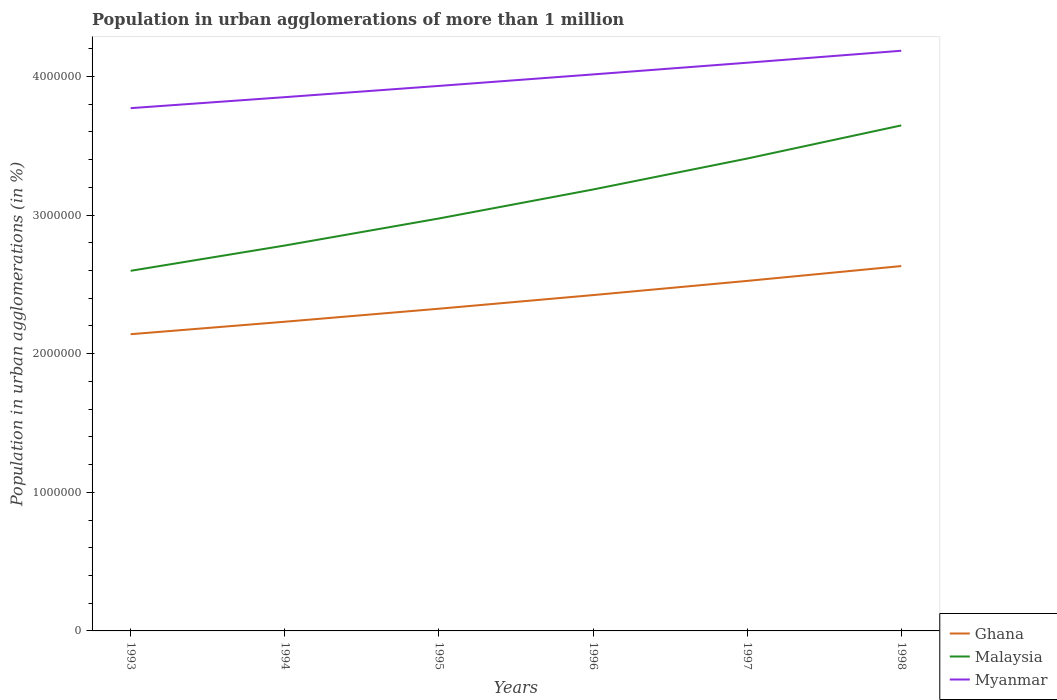How many different coloured lines are there?
Offer a very short reply. 3. Is the number of lines equal to the number of legend labels?
Provide a succinct answer. Yes. Across all years, what is the maximum population in urban agglomerations in Myanmar?
Your answer should be very brief. 3.77e+06. In which year was the population in urban agglomerations in Malaysia maximum?
Provide a succinct answer. 1993. What is the total population in urban agglomerations in Ghana in the graph?
Your answer should be very brief. -4.02e+05. What is the difference between the highest and the second highest population in urban agglomerations in Ghana?
Your answer should be very brief. 4.91e+05. Is the population in urban agglomerations in Malaysia strictly greater than the population in urban agglomerations in Myanmar over the years?
Give a very brief answer. Yes. What is the difference between two consecutive major ticks on the Y-axis?
Your answer should be compact. 1.00e+06. Where does the legend appear in the graph?
Make the answer very short. Bottom right. How many legend labels are there?
Your response must be concise. 3. How are the legend labels stacked?
Keep it short and to the point. Vertical. What is the title of the graph?
Keep it short and to the point. Population in urban agglomerations of more than 1 million. Does "Sao Tome and Principe" appear as one of the legend labels in the graph?
Your answer should be compact. No. What is the label or title of the Y-axis?
Offer a very short reply. Population in urban agglomerations (in %). What is the Population in urban agglomerations (in %) in Ghana in 1993?
Your answer should be very brief. 2.14e+06. What is the Population in urban agglomerations (in %) in Malaysia in 1993?
Your answer should be compact. 2.60e+06. What is the Population in urban agglomerations (in %) in Myanmar in 1993?
Give a very brief answer. 3.77e+06. What is the Population in urban agglomerations (in %) of Ghana in 1994?
Provide a short and direct response. 2.23e+06. What is the Population in urban agglomerations (in %) in Malaysia in 1994?
Offer a very short reply. 2.78e+06. What is the Population in urban agglomerations (in %) of Myanmar in 1994?
Ensure brevity in your answer.  3.85e+06. What is the Population in urban agglomerations (in %) of Ghana in 1995?
Provide a succinct answer. 2.32e+06. What is the Population in urban agglomerations (in %) of Malaysia in 1995?
Keep it short and to the point. 2.97e+06. What is the Population in urban agglomerations (in %) of Myanmar in 1995?
Make the answer very short. 3.93e+06. What is the Population in urban agglomerations (in %) in Ghana in 1996?
Offer a terse response. 2.42e+06. What is the Population in urban agglomerations (in %) of Malaysia in 1996?
Your response must be concise. 3.18e+06. What is the Population in urban agglomerations (in %) in Myanmar in 1996?
Your answer should be very brief. 4.01e+06. What is the Population in urban agglomerations (in %) in Ghana in 1997?
Your answer should be very brief. 2.52e+06. What is the Population in urban agglomerations (in %) in Malaysia in 1997?
Your answer should be compact. 3.41e+06. What is the Population in urban agglomerations (in %) in Myanmar in 1997?
Offer a very short reply. 4.10e+06. What is the Population in urban agglomerations (in %) in Ghana in 1998?
Offer a very short reply. 2.63e+06. What is the Population in urban agglomerations (in %) in Malaysia in 1998?
Give a very brief answer. 3.65e+06. What is the Population in urban agglomerations (in %) of Myanmar in 1998?
Offer a very short reply. 4.18e+06. Across all years, what is the maximum Population in urban agglomerations (in %) of Ghana?
Ensure brevity in your answer.  2.63e+06. Across all years, what is the maximum Population in urban agglomerations (in %) of Malaysia?
Make the answer very short. 3.65e+06. Across all years, what is the maximum Population in urban agglomerations (in %) in Myanmar?
Keep it short and to the point. 4.18e+06. Across all years, what is the minimum Population in urban agglomerations (in %) of Ghana?
Provide a short and direct response. 2.14e+06. Across all years, what is the minimum Population in urban agglomerations (in %) of Malaysia?
Your response must be concise. 2.60e+06. Across all years, what is the minimum Population in urban agglomerations (in %) in Myanmar?
Ensure brevity in your answer.  3.77e+06. What is the total Population in urban agglomerations (in %) of Ghana in the graph?
Provide a short and direct response. 1.43e+07. What is the total Population in urban agglomerations (in %) in Malaysia in the graph?
Make the answer very short. 1.86e+07. What is the total Population in urban agglomerations (in %) in Myanmar in the graph?
Your answer should be compact. 2.38e+07. What is the difference between the Population in urban agglomerations (in %) in Ghana in 1993 and that in 1994?
Your answer should be compact. -8.99e+04. What is the difference between the Population in urban agglomerations (in %) in Malaysia in 1993 and that in 1994?
Your answer should be compact. -1.82e+05. What is the difference between the Population in urban agglomerations (in %) in Myanmar in 1993 and that in 1994?
Offer a very short reply. -7.94e+04. What is the difference between the Population in urban agglomerations (in %) in Ghana in 1993 and that in 1995?
Provide a succinct answer. -1.84e+05. What is the difference between the Population in urban agglomerations (in %) in Malaysia in 1993 and that in 1995?
Offer a terse response. -3.77e+05. What is the difference between the Population in urban agglomerations (in %) of Myanmar in 1993 and that in 1995?
Ensure brevity in your answer.  -1.60e+05. What is the difference between the Population in urban agglomerations (in %) of Ghana in 1993 and that in 1996?
Ensure brevity in your answer.  -2.82e+05. What is the difference between the Population in urban agglomerations (in %) of Malaysia in 1993 and that in 1996?
Your response must be concise. -5.86e+05. What is the difference between the Population in urban agglomerations (in %) of Myanmar in 1993 and that in 1996?
Provide a succinct answer. -2.43e+05. What is the difference between the Population in urban agglomerations (in %) of Ghana in 1993 and that in 1997?
Your answer should be compact. -3.84e+05. What is the difference between the Population in urban agglomerations (in %) of Malaysia in 1993 and that in 1997?
Offer a very short reply. -8.10e+05. What is the difference between the Population in urban agglomerations (in %) of Myanmar in 1993 and that in 1997?
Your response must be concise. -3.28e+05. What is the difference between the Population in urban agglomerations (in %) in Ghana in 1993 and that in 1998?
Offer a very short reply. -4.91e+05. What is the difference between the Population in urban agglomerations (in %) in Malaysia in 1993 and that in 1998?
Provide a short and direct response. -1.05e+06. What is the difference between the Population in urban agglomerations (in %) in Myanmar in 1993 and that in 1998?
Provide a succinct answer. -4.14e+05. What is the difference between the Population in urban agglomerations (in %) in Ghana in 1994 and that in 1995?
Make the answer very short. -9.39e+04. What is the difference between the Population in urban agglomerations (in %) in Malaysia in 1994 and that in 1995?
Your answer should be very brief. -1.95e+05. What is the difference between the Population in urban agglomerations (in %) in Myanmar in 1994 and that in 1995?
Ensure brevity in your answer.  -8.11e+04. What is the difference between the Population in urban agglomerations (in %) in Ghana in 1994 and that in 1996?
Keep it short and to the point. -1.92e+05. What is the difference between the Population in urban agglomerations (in %) in Malaysia in 1994 and that in 1996?
Give a very brief answer. -4.04e+05. What is the difference between the Population in urban agglomerations (in %) of Myanmar in 1994 and that in 1996?
Offer a terse response. -1.64e+05. What is the difference between the Population in urban agglomerations (in %) in Ghana in 1994 and that in 1997?
Offer a very short reply. -2.95e+05. What is the difference between the Population in urban agglomerations (in %) in Malaysia in 1994 and that in 1997?
Offer a terse response. -6.27e+05. What is the difference between the Population in urban agglomerations (in %) in Myanmar in 1994 and that in 1997?
Your response must be concise. -2.48e+05. What is the difference between the Population in urban agglomerations (in %) in Ghana in 1994 and that in 1998?
Keep it short and to the point. -4.02e+05. What is the difference between the Population in urban agglomerations (in %) in Malaysia in 1994 and that in 1998?
Make the answer very short. -8.66e+05. What is the difference between the Population in urban agglomerations (in %) in Myanmar in 1994 and that in 1998?
Your answer should be compact. -3.35e+05. What is the difference between the Population in urban agglomerations (in %) in Ghana in 1995 and that in 1996?
Give a very brief answer. -9.82e+04. What is the difference between the Population in urban agglomerations (in %) in Malaysia in 1995 and that in 1996?
Your response must be concise. -2.09e+05. What is the difference between the Population in urban agglomerations (in %) in Myanmar in 1995 and that in 1996?
Offer a very short reply. -8.29e+04. What is the difference between the Population in urban agglomerations (in %) in Ghana in 1995 and that in 1997?
Your answer should be compact. -2.01e+05. What is the difference between the Population in urban agglomerations (in %) of Malaysia in 1995 and that in 1997?
Make the answer very short. -4.32e+05. What is the difference between the Population in urban agglomerations (in %) of Myanmar in 1995 and that in 1997?
Provide a succinct answer. -1.67e+05. What is the difference between the Population in urban agglomerations (in %) in Ghana in 1995 and that in 1998?
Provide a succinct answer. -3.08e+05. What is the difference between the Population in urban agglomerations (in %) of Malaysia in 1995 and that in 1998?
Give a very brief answer. -6.71e+05. What is the difference between the Population in urban agglomerations (in %) of Myanmar in 1995 and that in 1998?
Your answer should be very brief. -2.54e+05. What is the difference between the Population in urban agglomerations (in %) of Ghana in 1996 and that in 1997?
Your answer should be compact. -1.02e+05. What is the difference between the Population in urban agglomerations (in %) of Malaysia in 1996 and that in 1997?
Keep it short and to the point. -2.23e+05. What is the difference between the Population in urban agglomerations (in %) of Myanmar in 1996 and that in 1997?
Ensure brevity in your answer.  -8.44e+04. What is the difference between the Population in urban agglomerations (in %) of Ghana in 1996 and that in 1998?
Your answer should be very brief. -2.09e+05. What is the difference between the Population in urban agglomerations (in %) of Malaysia in 1996 and that in 1998?
Keep it short and to the point. -4.62e+05. What is the difference between the Population in urban agglomerations (in %) in Myanmar in 1996 and that in 1998?
Keep it short and to the point. -1.71e+05. What is the difference between the Population in urban agglomerations (in %) in Ghana in 1997 and that in 1998?
Your answer should be very brief. -1.07e+05. What is the difference between the Population in urban agglomerations (in %) in Malaysia in 1997 and that in 1998?
Give a very brief answer. -2.39e+05. What is the difference between the Population in urban agglomerations (in %) of Myanmar in 1997 and that in 1998?
Offer a very short reply. -8.63e+04. What is the difference between the Population in urban agglomerations (in %) of Ghana in 1993 and the Population in urban agglomerations (in %) of Malaysia in 1994?
Offer a terse response. -6.40e+05. What is the difference between the Population in urban agglomerations (in %) in Ghana in 1993 and the Population in urban agglomerations (in %) in Myanmar in 1994?
Your answer should be compact. -1.71e+06. What is the difference between the Population in urban agglomerations (in %) in Malaysia in 1993 and the Population in urban agglomerations (in %) in Myanmar in 1994?
Keep it short and to the point. -1.25e+06. What is the difference between the Population in urban agglomerations (in %) of Ghana in 1993 and the Population in urban agglomerations (in %) of Malaysia in 1995?
Provide a short and direct response. -8.35e+05. What is the difference between the Population in urban agglomerations (in %) in Ghana in 1993 and the Population in urban agglomerations (in %) in Myanmar in 1995?
Your response must be concise. -1.79e+06. What is the difference between the Population in urban agglomerations (in %) in Malaysia in 1993 and the Population in urban agglomerations (in %) in Myanmar in 1995?
Give a very brief answer. -1.33e+06. What is the difference between the Population in urban agglomerations (in %) in Ghana in 1993 and the Population in urban agglomerations (in %) in Malaysia in 1996?
Provide a short and direct response. -1.04e+06. What is the difference between the Population in urban agglomerations (in %) of Ghana in 1993 and the Population in urban agglomerations (in %) of Myanmar in 1996?
Offer a very short reply. -1.87e+06. What is the difference between the Population in urban agglomerations (in %) of Malaysia in 1993 and the Population in urban agglomerations (in %) of Myanmar in 1996?
Ensure brevity in your answer.  -1.42e+06. What is the difference between the Population in urban agglomerations (in %) in Ghana in 1993 and the Population in urban agglomerations (in %) in Malaysia in 1997?
Offer a very short reply. -1.27e+06. What is the difference between the Population in urban agglomerations (in %) of Ghana in 1993 and the Population in urban agglomerations (in %) of Myanmar in 1997?
Ensure brevity in your answer.  -1.96e+06. What is the difference between the Population in urban agglomerations (in %) in Malaysia in 1993 and the Population in urban agglomerations (in %) in Myanmar in 1997?
Provide a short and direct response. -1.50e+06. What is the difference between the Population in urban agglomerations (in %) in Ghana in 1993 and the Population in urban agglomerations (in %) in Malaysia in 1998?
Your answer should be compact. -1.51e+06. What is the difference between the Population in urban agglomerations (in %) of Ghana in 1993 and the Population in urban agglomerations (in %) of Myanmar in 1998?
Make the answer very short. -2.04e+06. What is the difference between the Population in urban agglomerations (in %) in Malaysia in 1993 and the Population in urban agglomerations (in %) in Myanmar in 1998?
Offer a terse response. -1.59e+06. What is the difference between the Population in urban agglomerations (in %) in Ghana in 1994 and the Population in urban agglomerations (in %) in Malaysia in 1995?
Offer a terse response. -7.45e+05. What is the difference between the Population in urban agglomerations (in %) in Ghana in 1994 and the Population in urban agglomerations (in %) in Myanmar in 1995?
Your answer should be compact. -1.70e+06. What is the difference between the Population in urban agglomerations (in %) in Malaysia in 1994 and the Population in urban agglomerations (in %) in Myanmar in 1995?
Offer a terse response. -1.15e+06. What is the difference between the Population in urban agglomerations (in %) in Ghana in 1994 and the Population in urban agglomerations (in %) in Malaysia in 1996?
Offer a very short reply. -9.54e+05. What is the difference between the Population in urban agglomerations (in %) in Ghana in 1994 and the Population in urban agglomerations (in %) in Myanmar in 1996?
Offer a very short reply. -1.78e+06. What is the difference between the Population in urban agglomerations (in %) of Malaysia in 1994 and the Population in urban agglomerations (in %) of Myanmar in 1996?
Ensure brevity in your answer.  -1.23e+06. What is the difference between the Population in urban agglomerations (in %) of Ghana in 1994 and the Population in urban agglomerations (in %) of Malaysia in 1997?
Your response must be concise. -1.18e+06. What is the difference between the Population in urban agglomerations (in %) of Ghana in 1994 and the Population in urban agglomerations (in %) of Myanmar in 1997?
Your response must be concise. -1.87e+06. What is the difference between the Population in urban agglomerations (in %) in Malaysia in 1994 and the Population in urban agglomerations (in %) in Myanmar in 1997?
Provide a succinct answer. -1.32e+06. What is the difference between the Population in urban agglomerations (in %) of Ghana in 1994 and the Population in urban agglomerations (in %) of Malaysia in 1998?
Your response must be concise. -1.42e+06. What is the difference between the Population in urban agglomerations (in %) in Ghana in 1994 and the Population in urban agglomerations (in %) in Myanmar in 1998?
Make the answer very short. -1.95e+06. What is the difference between the Population in urban agglomerations (in %) of Malaysia in 1994 and the Population in urban agglomerations (in %) of Myanmar in 1998?
Provide a short and direct response. -1.40e+06. What is the difference between the Population in urban agglomerations (in %) in Ghana in 1995 and the Population in urban agglomerations (in %) in Malaysia in 1996?
Your response must be concise. -8.60e+05. What is the difference between the Population in urban agglomerations (in %) in Ghana in 1995 and the Population in urban agglomerations (in %) in Myanmar in 1996?
Offer a terse response. -1.69e+06. What is the difference between the Population in urban agglomerations (in %) of Malaysia in 1995 and the Population in urban agglomerations (in %) of Myanmar in 1996?
Keep it short and to the point. -1.04e+06. What is the difference between the Population in urban agglomerations (in %) of Ghana in 1995 and the Population in urban agglomerations (in %) of Malaysia in 1997?
Offer a very short reply. -1.08e+06. What is the difference between the Population in urban agglomerations (in %) in Ghana in 1995 and the Population in urban agglomerations (in %) in Myanmar in 1997?
Provide a short and direct response. -1.77e+06. What is the difference between the Population in urban agglomerations (in %) of Malaysia in 1995 and the Population in urban agglomerations (in %) of Myanmar in 1997?
Ensure brevity in your answer.  -1.12e+06. What is the difference between the Population in urban agglomerations (in %) in Ghana in 1995 and the Population in urban agglomerations (in %) in Malaysia in 1998?
Your answer should be very brief. -1.32e+06. What is the difference between the Population in urban agglomerations (in %) in Ghana in 1995 and the Population in urban agglomerations (in %) in Myanmar in 1998?
Provide a short and direct response. -1.86e+06. What is the difference between the Population in urban agglomerations (in %) of Malaysia in 1995 and the Population in urban agglomerations (in %) of Myanmar in 1998?
Give a very brief answer. -1.21e+06. What is the difference between the Population in urban agglomerations (in %) in Ghana in 1996 and the Population in urban agglomerations (in %) in Malaysia in 1997?
Offer a very short reply. -9.85e+05. What is the difference between the Population in urban agglomerations (in %) of Ghana in 1996 and the Population in urban agglomerations (in %) of Myanmar in 1997?
Your answer should be compact. -1.68e+06. What is the difference between the Population in urban agglomerations (in %) of Malaysia in 1996 and the Population in urban agglomerations (in %) of Myanmar in 1997?
Keep it short and to the point. -9.14e+05. What is the difference between the Population in urban agglomerations (in %) in Ghana in 1996 and the Population in urban agglomerations (in %) in Malaysia in 1998?
Your response must be concise. -1.22e+06. What is the difference between the Population in urban agglomerations (in %) in Ghana in 1996 and the Population in urban agglomerations (in %) in Myanmar in 1998?
Ensure brevity in your answer.  -1.76e+06. What is the difference between the Population in urban agglomerations (in %) of Malaysia in 1996 and the Population in urban agglomerations (in %) of Myanmar in 1998?
Provide a short and direct response. -1.00e+06. What is the difference between the Population in urban agglomerations (in %) in Ghana in 1997 and the Population in urban agglomerations (in %) in Malaysia in 1998?
Offer a terse response. -1.12e+06. What is the difference between the Population in urban agglomerations (in %) in Ghana in 1997 and the Population in urban agglomerations (in %) in Myanmar in 1998?
Give a very brief answer. -1.66e+06. What is the difference between the Population in urban agglomerations (in %) of Malaysia in 1997 and the Population in urban agglomerations (in %) of Myanmar in 1998?
Your answer should be compact. -7.78e+05. What is the average Population in urban agglomerations (in %) in Ghana per year?
Keep it short and to the point. 2.38e+06. What is the average Population in urban agglomerations (in %) in Malaysia per year?
Ensure brevity in your answer.  3.10e+06. What is the average Population in urban agglomerations (in %) of Myanmar per year?
Offer a very short reply. 3.97e+06. In the year 1993, what is the difference between the Population in urban agglomerations (in %) in Ghana and Population in urban agglomerations (in %) in Malaysia?
Make the answer very short. -4.57e+05. In the year 1993, what is the difference between the Population in urban agglomerations (in %) of Ghana and Population in urban agglomerations (in %) of Myanmar?
Give a very brief answer. -1.63e+06. In the year 1993, what is the difference between the Population in urban agglomerations (in %) in Malaysia and Population in urban agglomerations (in %) in Myanmar?
Offer a terse response. -1.17e+06. In the year 1994, what is the difference between the Population in urban agglomerations (in %) of Ghana and Population in urban agglomerations (in %) of Malaysia?
Your response must be concise. -5.50e+05. In the year 1994, what is the difference between the Population in urban agglomerations (in %) in Ghana and Population in urban agglomerations (in %) in Myanmar?
Your answer should be very brief. -1.62e+06. In the year 1994, what is the difference between the Population in urban agglomerations (in %) of Malaysia and Population in urban agglomerations (in %) of Myanmar?
Give a very brief answer. -1.07e+06. In the year 1995, what is the difference between the Population in urban agglomerations (in %) of Ghana and Population in urban agglomerations (in %) of Malaysia?
Give a very brief answer. -6.51e+05. In the year 1995, what is the difference between the Population in urban agglomerations (in %) in Ghana and Population in urban agglomerations (in %) in Myanmar?
Provide a short and direct response. -1.61e+06. In the year 1995, what is the difference between the Population in urban agglomerations (in %) in Malaysia and Population in urban agglomerations (in %) in Myanmar?
Offer a very short reply. -9.56e+05. In the year 1996, what is the difference between the Population in urban agglomerations (in %) in Ghana and Population in urban agglomerations (in %) in Malaysia?
Offer a very short reply. -7.62e+05. In the year 1996, what is the difference between the Population in urban agglomerations (in %) in Ghana and Population in urban agglomerations (in %) in Myanmar?
Provide a succinct answer. -1.59e+06. In the year 1996, what is the difference between the Population in urban agglomerations (in %) of Malaysia and Population in urban agglomerations (in %) of Myanmar?
Ensure brevity in your answer.  -8.30e+05. In the year 1997, what is the difference between the Population in urban agglomerations (in %) of Ghana and Population in urban agglomerations (in %) of Malaysia?
Provide a succinct answer. -8.83e+05. In the year 1997, what is the difference between the Population in urban agglomerations (in %) in Ghana and Population in urban agglomerations (in %) in Myanmar?
Make the answer very short. -1.57e+06. In the year 1997, what is the difference between the Population in urban agglomerations (in %) in Malaysia and Population in urban agglomerations (in %) in Myanmar?
Provide a succinct answer. -6.91e+05. In the year 1998, what is the difference between the Population in urban agglomerations (in %) of Ghana and Population in urban agglomerations (in %) of Malaysia?
Make the answer very short. -1.01e+06. In the year 1998, what is the difference between the Population in urban agglomerations (in %) of Ghana and Population in urban agglomerations (in %) of Myanmar?
Your answer should be very brief. -1.55e+06. In the year 1998, what is the difference between the Population in urban agglomerations (in %) of Malaysia and Population in urban agglomerations (in %) of Myanmar?
Your response must be concise. -5.39e+05. What is the ratio of the Population in urban agglomerations (in %) of Ghana in 1993 to that in 1994?
Provide a succinct answer. 0.96. What is the ratio of the Population in urban agglomerations (in %) in Malaysia in 1993 to that in 1994?
Ensure brevity in your answer.  0.93. What is the ratio of the Population in urban agglomerations (in %) in Myanmar in 1993 to that in 1994?
Provide a succinct answer. 0.98. What is the ratio of the Population in urban agglomerations (in %) in Ghana in 1993 to that in 1995?
Ensure brevity in your answer.  0.92. What is the ratio of the Population in urban agglomerations (in %) in Malaysia in 1993 to that in 1995?
Your response must be concise. 0.87. What is the ratio of the Population in urban agglomerations (in %) in Myanmar in 1993 to that in 1995?
Ensure brevity in your answer.  0.96. What is the ratio of the Population in urban agglomerations (in %) in Ghana in 1993 to that in 1996?
Provide a succinct answer. 0.88. What is the ratio of the Population in urban agglomerations (in %) of Malaysia in 1993 to that in 1996?
Your answer should be compact. 0.82. What is the ratio of the Population in urban agglomerations (in %) of Myanmar in 1993 to that in 1996?
Offer a terse response. 0.94. What is the ratio of the Population in urban agglomerations (in %) of Ghana in 1993 to that in 1997?
Keep it short and to the point. 0.85. What is the ratio of the Population in urban agglomerations (in %) in Malaysia in 1993 to that in 1997?
Offer a terse response. 0.76. What is the ratio of the Population in urban agglomerations (in %) in Myanmar in 1993 to that in 1997?
Your answer should be compact. 0.92. What is the ratio of the Population in urban agglomerations (in %) of Ghana in 1993 to that in 1998?
Offer a very short reply. 0.81. What is the ratio of the Population in urban agglomerations (in %) of Malaysia in 1993 to that in 1998?
Provide a succinct answer. 0.71. What is the ratio of the Population in urban agglomerations (in %) of Myanmar in 1993 to that in 1998?
Make the answer very short. 0.9. What is the ratio of the Population in urban agglomerations (in %) of Ghana in 1994 to that in 1995?
Your answer should be very brief. 0.96. What is the ratio of the Population in urban agglomerations (in %) of Malaysia in 1994 to that in 1995?
Your answer should be very brief. 0.93. What is the ratio of the Population in urban agglomerations (in %) of Myanmar in 1994 to that in 1995?
Keep it short and to the point. 0.98. What is the ratio of the Population in urban agglomerations (in %) of Ghana in 1994 to that in 1996?
Offer a very short reply. 0.92. What is the ratio of the Population in urban agglomerations (in %) of Malaysia in 1994 to that in 1996?
Offer a terse response. 0.87. What is the ratio of the Population in urban agglomerations (in %) of Myanmar in 1994 to that in 1996?
Provide a short and direct response. 0.96. What is the ratio of the Population in urban agglomerations (in %) of Ghana in 1994 to that in 1997?
Offer a terse response. 0.88. What is the ratio of the Population in urban agglomerations (in %) of Malaysia in 1994 to that in 1997?
Offer a terse response. 0.82. What is the ratio of the Population in urban agglomerations (in %) of Myanmar in 1994 to that in 1997?
Give a very brief answer. 0.94. What is the ratio of the Population in urban agglomerations (in %) in Ghana in 1994 to that in 1998?
Ensure brevity in your answer.  0.85. What is the ratio of the Population in urban agglomerations (in %) in Malaysia in 1994 to that in 1998?
Ensure brevity in your answer.  0.76. What is the ratio of the Population in urban agglomerations (in %) in Myanmar in 1994 to that in 1998?
Your response must be concise. 0.92. What is the ratio of the Population in urban agglomerations (in %) of Ghana in 1995 to that in 1996?
Offer a terse response. 0.96. What is the ratio of the Population in urban agglomerations (in %) in Malaysia in 1995 to that in 1996?
Your answer should be very brief. 0.93. What is the ratio of the Population in urban agglomerations (in %) in Myanmar in 1995 to that in 1996?
Your answer should be compact. 0.98. What is the ratio of the Population in urban agglomerations (in %) in Ghana in 1995 to that in 1997?
Your response must be concise. 0.92. What is the ratio of the Population in urban agglomerations (in %) in Malaysia in 1995 to that in 1997?
Give a very brief answer. 0.87. What is the ratio of the Population in urban agglomerations (in %) of Myanmar in 1995 to that in 1997?
Your answer should be very brief. 0.96. What is the ratio of the Population in urban agglomerations (in %) of Ghana in 1995 to that in 1998?
Make the answer very short. 0.88. What is the ratio of the Population in urban agglomerations (in %) of Malaysia in 1995 to that in 1998?
Offer a terse response. 0.82. What is the ratio of the Population in urban agglomerations (in %) of Myanmar in 1995 to that in 1998?
Provide a short and direct response. 0.94. What is the ratio of the Population in urban agglomerations (in %) in Ghana in 1996 to that in 1997?
Your answer should be very brief. 0.96. What is the ratio of the Population in urban agglomerations (in %) of Malaysia in 1996 to that in 1997?
Your response must be concise. 0.93. What is the ratio of the Population in urban agglomerations (in %) in Myanmar in 1996 to that in 1997?
Provide a short and direct response. 0.98. What is the ratio of the Population in urban agglomerations (in %) of Ghana in 1996 to that in 1998?
Give a very brief answer. 0.92. What is the ratio of the Population in urban agglomerations (in %) in Malaysia in 1996 to that in 1998?
Ensure brevity in your answer.  0.87. What is the ratio of the Population in urban agglomerations (in %) of Myanmar in 1996 to that in 1998?
Offer a very short reply. 0.96. What is the ratio of the Population in urban agglomerations (in %) in Ghana in 1997 to that in 1998?
Your response must be concise. 0.96. What is the ratio of the Population in urban agglomerations (in %) of Malaysia in 1997 to that in 1998?
Offer a very short reply. 0.93. What is the ratio of the Population in urban agglomerations (in %) of Myanmar in 1997 to that in 1998?
Your answer should be very brief. 0.98. What is the difference between the highest and the second highest Population in urban agglomerations (in %) in Ghana?
Ensure brevity in your answer.  1.07e+05. What is the difference between the highest and the second highest Population in urban agglomerations (in %) in Malaysia?
Provide a succinct answer. 2.39e+05. What is the difference between the highest and the second highest Population in urban agglomerations (in %) in Myanmar?
Give a very brief answer. 8.63e+04. What is the difference between the highest and the lowest Population in urban agglomerations (in %) in Ghana?
Give a very brief answer. 4.91e+05. What is the difference between the highest and the lowest Population in urban agglomerations (in %) in Malaysia?
Offer a very short reply. 1.05e+06. What is the difference between the highest and the lowest Population in urban agglomerations (in %) of Myanmar?
Make the answer very short. 4.14e+05. 